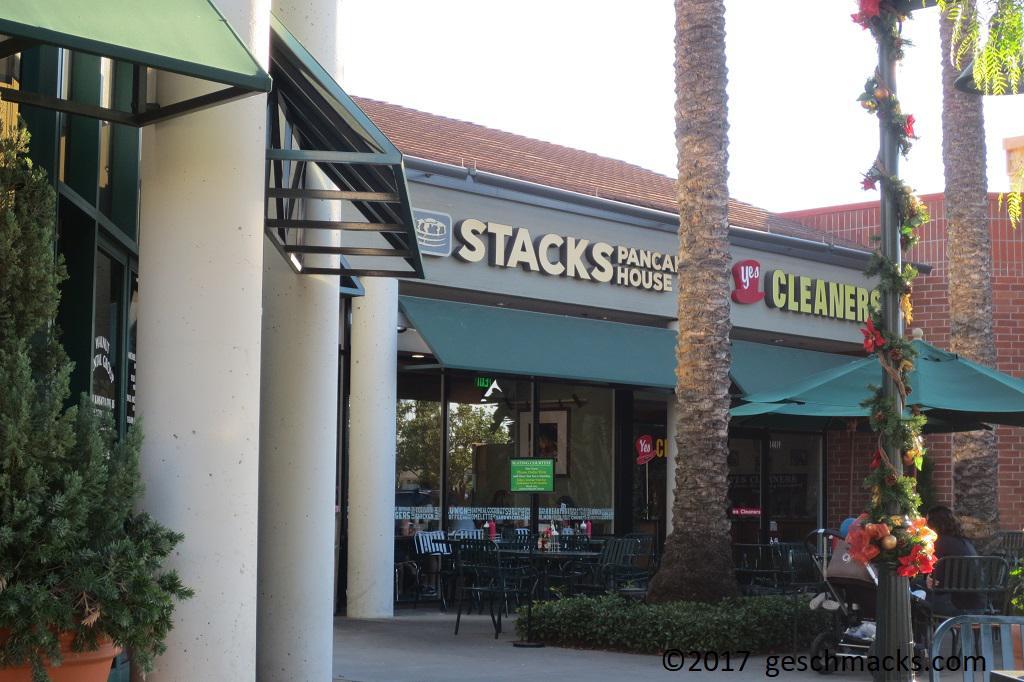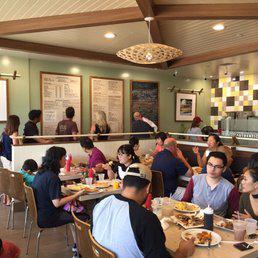The first image is the image on the left, the second image is the image on the right. Given the left and right images, does the statement "Someone is reading the menu board." hold true? Answer yes or no. Yes. The first image is the image on the left, the second image is the image on the right. Evaluate the accuracy of this statement regarding the images: "At least one of the images includes stained wooden beams on the ceiling.". Is it true? Answer yes or no. Yes. 